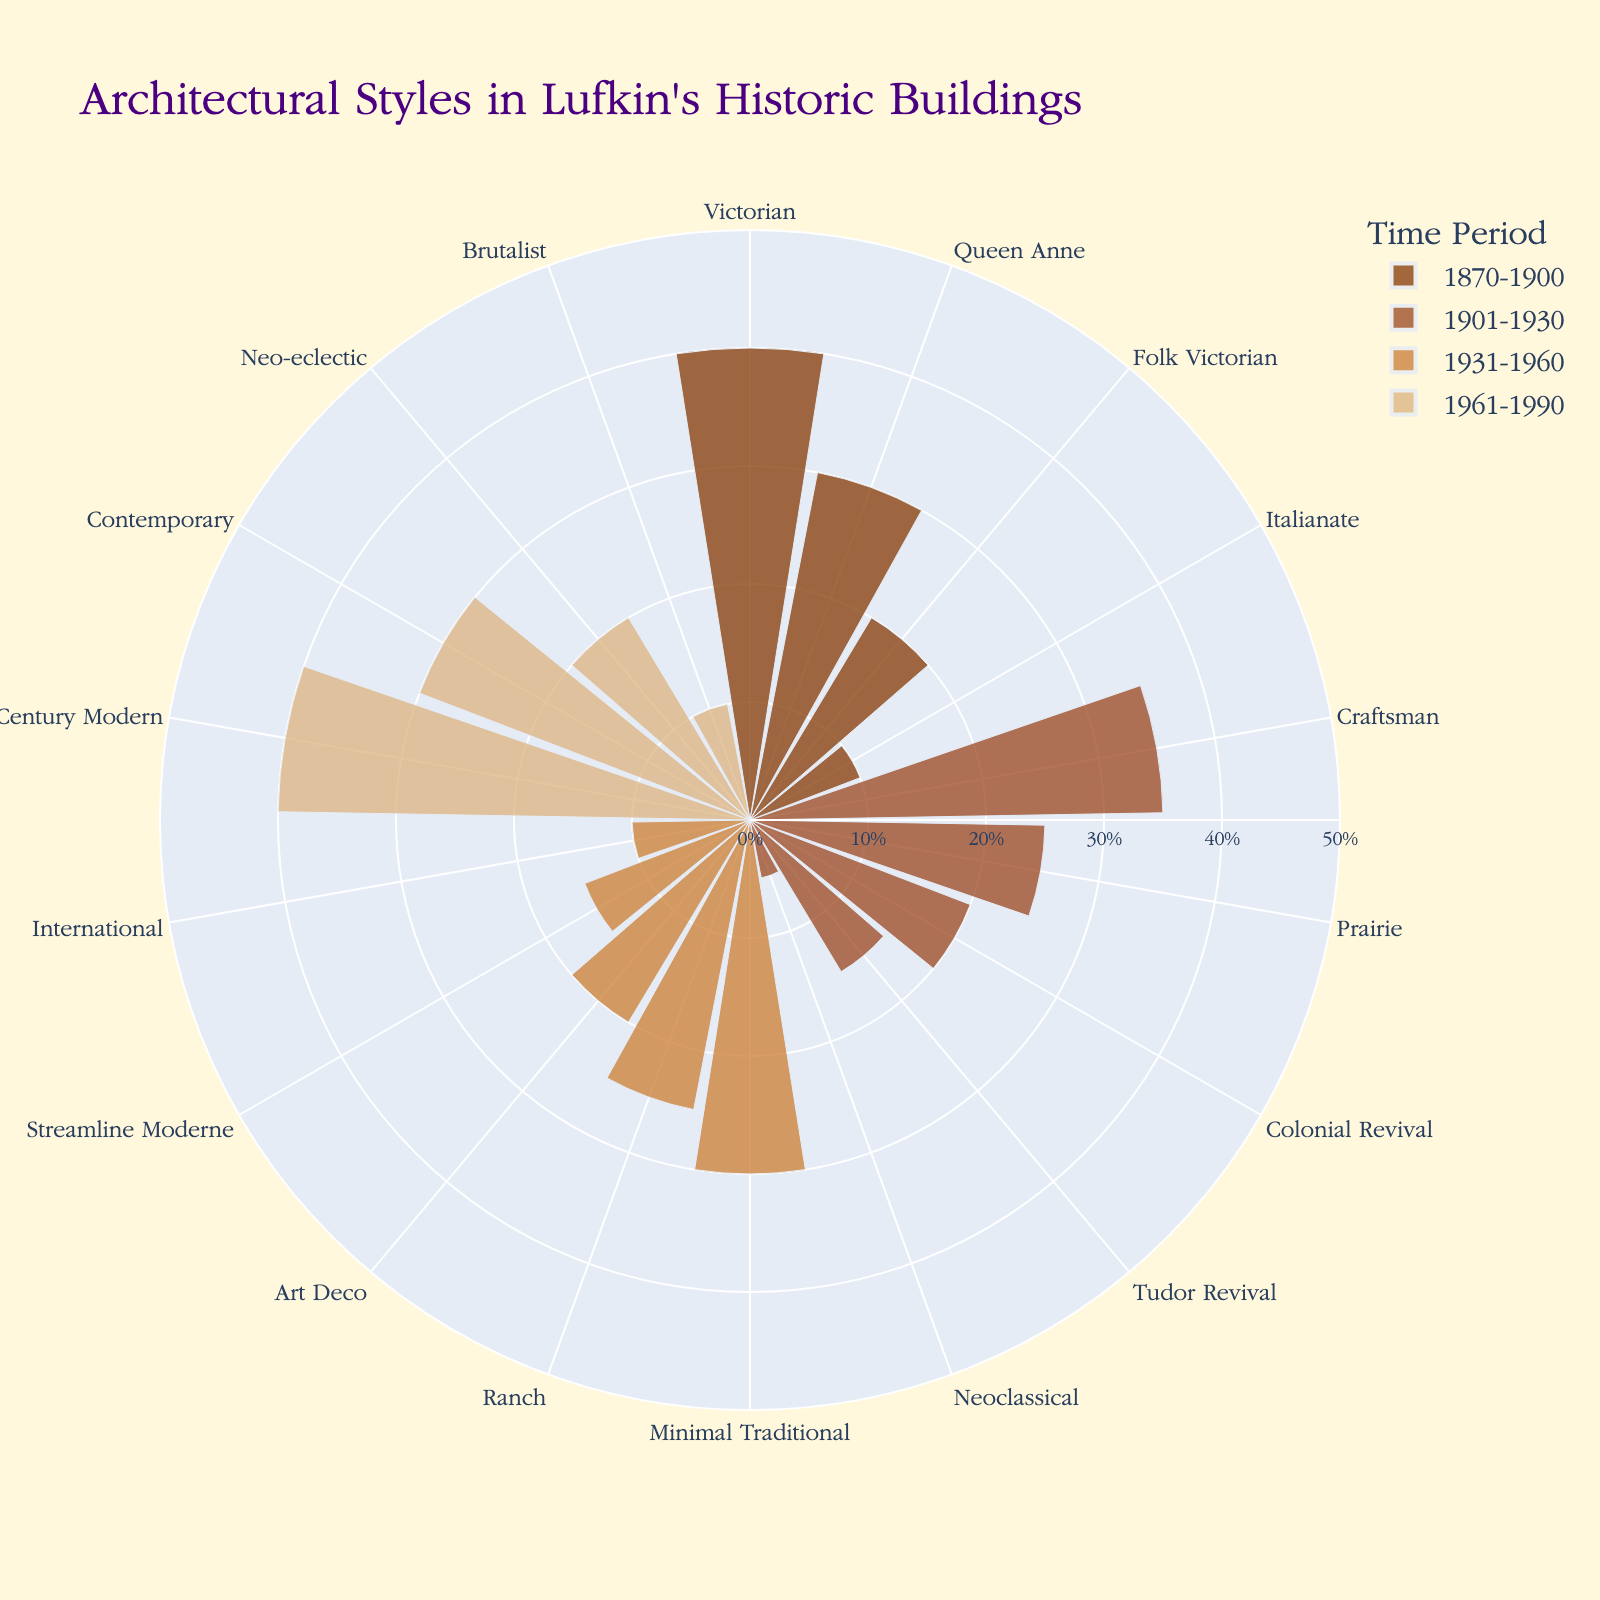What is the title of the figure? The title of the figure is usually displayed prominently at the top. For this figure, it is described in the provided data and code.
Answer: Architectural Styles in Lufkin's Historic Buildings Which architectural style is most dominant in the time period 1870-1900? Referring to the segment of the chart labeled 1870-1900, observe the proportionate sizes of different styles.
Answer: Victorian How many architectural styles are depicted for the time period 1931-1960? Count the number of different labels within the segment representing 1931-1960.
Answer: Five What color represents the 1901-1930 time period? Colors are assigned to different time periods as described in the code. Look for the color associated with the segment for 1901-1930.
Answer: A0522D (a shade of brown) Which time period has the highest percentage for a single architectural style? Compare the highest percentage values of architectural styles across different time periods.
Answer: 1961-1990 (Mid-Century Modern, 40%) What is the combined percentage of Victorian and Queen Anne styles in the 1870-1900 period? Add the percentages of Victorian and Queen Anne within the 1870-1900 period: 40% + 30%.
Answer: 70% Compare the percentage of Craftsman style in 1901-1930 to the percentage of Minimal Traditional in 1931-1960. Which is higher? Evaluate the percentages for Craftsman (1901-1930) and Minimal Traditional (1931-1960). Craftsman has 35%, whereas Minimal Traditional has 30%.
Answer: Craftsman is higher What is the average percentage of all architectural styles in the 1961-1990 period? Sum the percentages of all styles within 1961-1990 and divide by the number of styles (40 + 30 + 20 + 10) / 4.
Answer: 25% Which architectural styles appear in more than one time period? Review the architectural styles listed in each period and identify those recurring in multiple periods.
Answer: None What percentage of the overall chart does Folk Victorian from 1870-1900 represent? Examine the percentage specifically for Folk Victorian in the 1870-1900 section, which is directly labeled.
Answer: 20% 